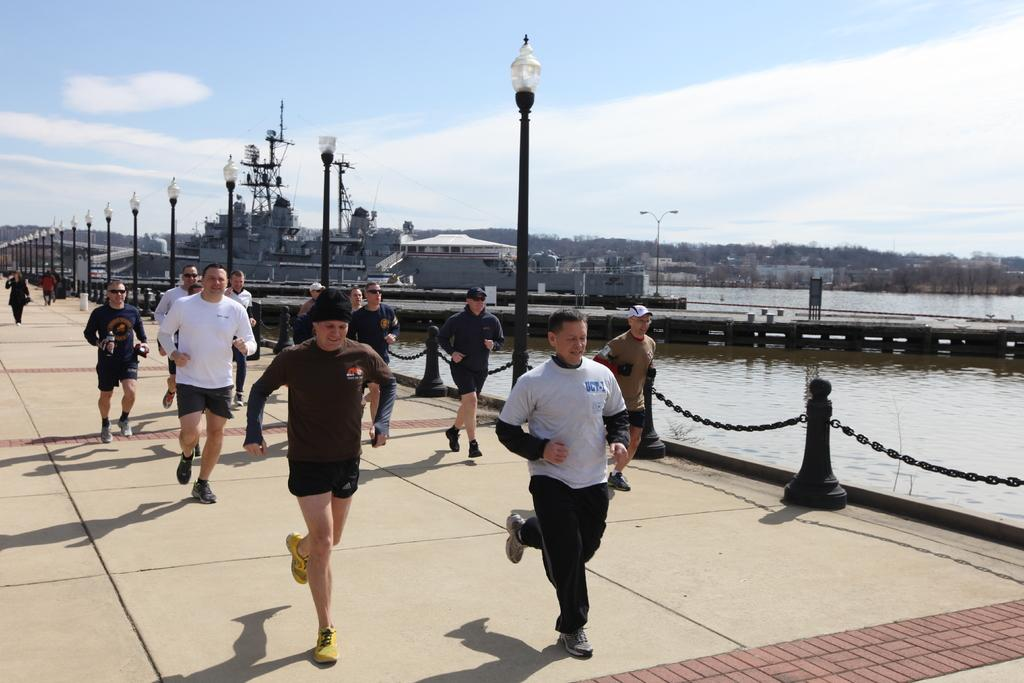What are the people in the image doing? The people in the image are running on the bridge. What can be seen beside the bridge? There are street light poles beside the bridge. What is visible in the background of the image? There is water, mountains, and buildings visible in the image. What committee is responsible for the design of the print on the bridge? There is no committee or print mentioned in the image; it simply shows people running on a bridge with a background of water, mountains, and buildings. 